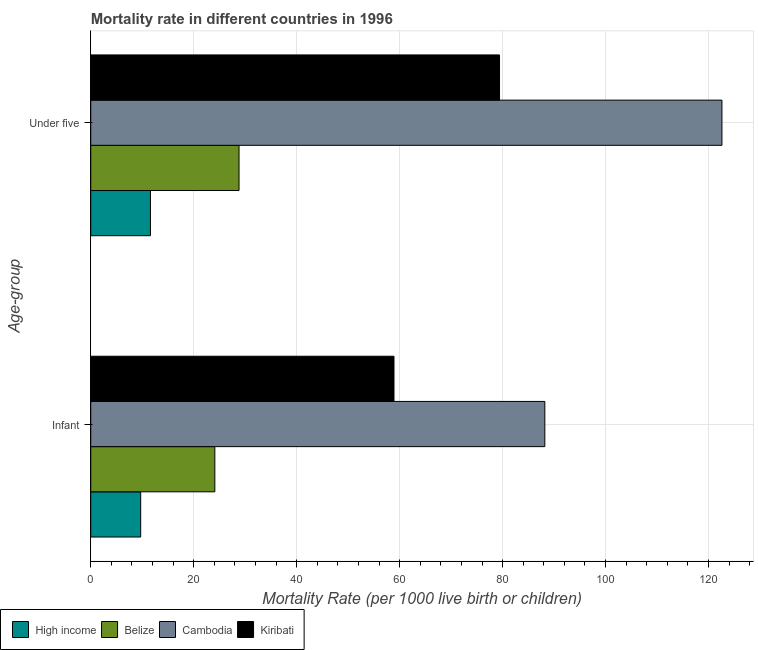Are the number of bars on each tick of the Y-axis equal?
Keep it short and to the point. Yes. How many bars are there on the 1st tick from the bottom?
Make the answer very short. 4. What is the label of the 1st group of bars from the top?
Make the answer very short. Under five. What is the under-5 mortality rate in Belize?
Your response must be concise. 28.8. Across all countries, what is the maximum infant mortality rate?
Offer a terse response. 88.2. In which country was the under-5 mortality rate maximum?
Your response must be concise. Cambodia. In which country was the under-5 mortality rate minimum?
Offer a terse response. High income. What is the total infant mortality rate in the graph?
Your answer should be compact. 180.9. What is the difference between the under-5 mortality rate in Belize and that in Kiribati?
Your answer should be very brief. -50.6. What is the difference between the infant mortality rate in Kiribati and the under-5 mortality rate in High income?
Ensure brevity in your answer.  47.3. What is the average infant mortality rate per country?
Keep it short and to the point. 45.23. What is the difference between the under-5 mortality rate and infant mortality rate in Belize?
Provide a succinct answer. 4.7. In how many countries, is the infant mortality rate greater than 48 ?
Your response must be concise. 2. What is the ratio of the infant mortality rate in Kiribati to that in Cambodia?
Make the answer very short. 0.67. What does the 3rd bar from the top in Under five represents?
Your answer should be very brief. Belize. What does the 3rd bar from the bottom in Infant represents?
Offer a terse response. Cambodia. How many countries are there in the graph?
Offer a terse response. 4. What is the difference between two consecutive major ticks on the X-axis?
Ensure brevity in your answer.  20. Does the graph contain grids?
Provide a short and direct response. Yes. How many legend labels are there?
Make the answer very short. 4. What is the title of the graph?
Your response must be concise. Mortality rate in different countries in 1996. What is the label or title of the X-axis?
Provide a short and direct response. Mortality Rate (per 1000 live birth or children). What is the label or title of the Y-axis?
Your answer should be very brief. Age-group. What is the Mortality Rate (per 1000 live birth or children) of Belize in Infant?
Keep it short and to the point. 24.1. What is the Mortality Rate (per 1000 live birth or children) of Cambodia in Infant?
Your answer should be compact. 88.2. What is the Mortality Rate (per 1000 live birth or children) of Kiribati in Infant?
Provide a succinct answer. 58.9. What is the Mortality Rate (per 1000 live birth or children) of High income in Under five?
Ensure brevity in your answer.  11.6. What is the Mortality Rate (per 1000 live birth or children) of Belize in Under five?
Your response must be concise. 28.8. What is the Mortality Rate (per 1000 live birth or children) of Cambodia in Under five?
Your answer should be very brief. 122.6. What is the Mortality Rate (per 1000 live birth or children) of Kiribati in Under five?
Provide a short and direct response. 79.4. Across all Age-group, what is the maximum Mortality Rate (per 1000 live birth or children) of High income?
Make the answer very short. 11.6. Across all Age-group, what is the maximum Mortality Rate (per 1000 live birth or children) in Belize?
Offer a terse response. 28.8. Across all Age-group, what is the maximum Mortality Rate (per 1000 live birth or children) of Cambodia?
Make the answer very short. 122.6. Across all Age-group, what is the maximum Mortality Rate (per 1000 live birth or children) in Kiribati?
Make the answer very short. 79.4. Across all Age-group, what is the minimum Mortality Rate (per 1000 live birth or children) in High income?
Keep it short and to the point. 9.7. Across all Age-group, what is the minimum Mortality Rate (per 1000 live birth or children) of Belize?
Your response must be concise. 24.1. Across all Age-group, what is the minimum Mortality Rate (per 1000 live birth or children) in Cambodia?
Ensure brevity in your answer.  88.2. Across all Age-group, what is the minimum Mortality Rate (per 1000 live birth or children) in Kiribati?
Provide a short and direct response. 58.9. What is the total Mortality Rate (per 1000 live birth or children) in High income in the graph?
Ensure brevity in your answer.  21.3. What is the total Mortality Rate (per 1000 live birth or children) in Belize in the graph?
Your answer should be compact. 52.9. What is the total Mortality Rate (per 1000 live birth or children) in Cambodia in the graph?
Provide a short and direct response. 210.8. What is the total Mortality Rate (per 1000 live birth or children) in Kiribati in the graph?
Offer a very short reply. 138.3. What is the difference between the Mortality Rate (per 1000 live birth or children) of High income in Infant and that in Under five?
Provide a short and direct response. -1.9. What is the difference between the Mortality Rate (per 1000 live birth or children) of Cambodia in Infant and that in Under five?
Make the answer very short. -34.4. What is the difference between the Mortality Rate (per 1000 live birth or children) of Kiribati in Infant and that in Under five?
Your answer should be very brief. -20.5. What is the difference between the Mortality Rate (per 1000 live birth or children) of High income in Infant and the Mortality Rate (per 1000 live birth or children) of Belize in Under five?
Keep it short and to the point. -19.1. What is the difference between the Mortality Rate (per 1000 live birth or children) in High income in Infant and the Mortality Rate (per 1000 live birth or children) in Cambodia in Under five?
Give a very brief answer. -112.9. What is the difference between the Mortality Rate (per 1000 live birth or children) of High income in Infant and the Mortality Rate (per 1000 live birth or children) of Kiribati in Under five?
Ensure brevity in your answer.  -69.7. What is the difference between the Mortality Rate (per 1000 live birth or children) of Belize in Infant and the Mortality Rate (per 1000 live birth or children) of Cambodia in Under five?
Provide a succinct answer. -98.5. What is the difference between the Mortality Rate (per 1000 live birth or children) of Belize in Infant and the Mortality Rate (per 1000 live birth or children) of Kiribati in Under five?
Your answer should be compact. -55.3. What is the difference between the Mortality Rate (per 1000 live birth or children) in Cambodia in Infant and the Mortality Rate (per 1000 live birth or children) in Kiribati in Under five?
Keep it short and to the point. 8.8. What is the average Mortality Rate (per 1000 live birth or children) of High income per Age-group?
Provide a short and direct response. 10.65. What is the average Mortality Rate (per 1000 live birth or children) in Belize per Age-group?
Your answer should be compact. 26.45. What is the average Mortality Rate (per 1000 live birth or children) in Cambodia per Age-group?
Your answer should be compact. 105.4. What is the average Mortality Rate (per 1000 live birth or children) in Kiribati per Age-group?
Offer a terse response. 69.15. What is the difference between the Mortality Rate (per 1000 live birth or children) in High income and Mortality Rate (per 1000 live birth or children) in Belize in Infant?
Provide a short and direct response. -14.4. What is the difference between the Mortality Rate (per 1000 live birth or children) of High income and Mortality Rate (per 1000 live birth or children) of Cambodia in Infant?
Keep it short and to the point. -78.5. What is the difference between the Mortality Rate (per 1000 live birth or children) in High income and Mortality Rate (per 1000 live birth or children) in Kiribati in Infant?
Ensure brevity in your answer.  -49.2. What is the difference between the Mortality Rate (per 1000 live birth or children) of Belize and Mortality Rate (per 1000 live birth or children) of Cambodia in Infant?
Your response must be concise. -64.1. What is the difference between the Mortality Rate (per 1000 live birth or children) in Belize and Mortality Rate (per 1000 live birth or children) in Kiribati in Infant?
Offer a terse response. -34.8. What is the difference between the Mortality Rate (per 1000 live birth or children) in Cambodia and Mortality Rate (per 1000 live birth or children) in Kiribati in Infant?
Offer a terse response. 29.3. What is the difference between the Mortality Rate (per 1000 live birth or children) of High income and Mortality Rate (per 1000 live birth or children) of Belize in Under five?
Your answer should be compact. -17.2. What is the difference between the Mortality Rate (per 1000 live birth or children) in High income and Mortality Rate (per 1000 live birth or children) in Cambodia in Under five?
Make the answer very short. -111. What is the difference between the Mortality Rate (per 1000 live birth or children) of High income and Mortality Rate (per 1000 live birth or children) of Kiribati in Under five?
Keep it short and to the point. -67.8. What is the difference between the Mortality Rate (per 1000 live birth or children) of Belize and Mortality Rate (per 1000 live birth or children) of Cambodia in Under five?
Ensure brevity in your answer.  -93.8. What is the difference between the Mortality Rate (per 1000 live birth or children) of Belize and Mortality Rate (per 1000 live birth or children) of Kiribati in Under five?
Provide a short and direct response. -50.6. What is the difference between the Mortality Rate (per 1000 live birth or children) in Cambodia and Mortality Rate (per 1000 live birth or children) in Kiribati in Under five?
Offer a very short reply. 43.2. What is the ratio of the Mortality Rate (per 1000 live birth or children) of High income in Infant to that in Under five?
Your answer should be compact. 0.84. What is the ratio of the Mortality Rate (per 1000 live birth or children) of Belize in Infant to that in Under five?
Your answer should be compact. 0.84. What is the ratio of the Mortality Rate (per 1000 live birth or children) in Cambodia in Infant to that in Under five?
Make the answer very short. 0.72. What is the ratio of the Mortality Rate (per 1000 live birth or children) of Kiribati in Infant to that in Under five?
Provide a succinct answer. 0.74. What is the difference between the highest and the second highest Mortality Rate (per 1000 live birth or children) of High income?
Provide a short and direct response. 1.9. What is the difference between the highest and the second highest Mortality Rate (per 1000 live birth or children) in Cambodia?
Give a very brief answer. 34.4. What is the difference between the highest and the second highest Mortality Rate (per 1000 live birth or children) in Kiribati?
Your answer should be very brief. 20.5. What is the difference between the highest and the lowest Mortality Rate (per 1000 live birth or children) of High income?
Offer a very short reply. 1.9. What is the difference between the highest and the lowest Mortality Rate (per 1000 live birth or children) of Belize?
Offer a very short reply. 4.7. What is the difference between the highest and the lowest Mortality Rate (per 1000 live birth or children) in Cambodia?
Provide a short and direct response. 34.4. What is the difference between the highest and the lowest Mortality Rate (per 1000 live birth or children) in Kiribati?
Give a very brief answer. 20.5. 